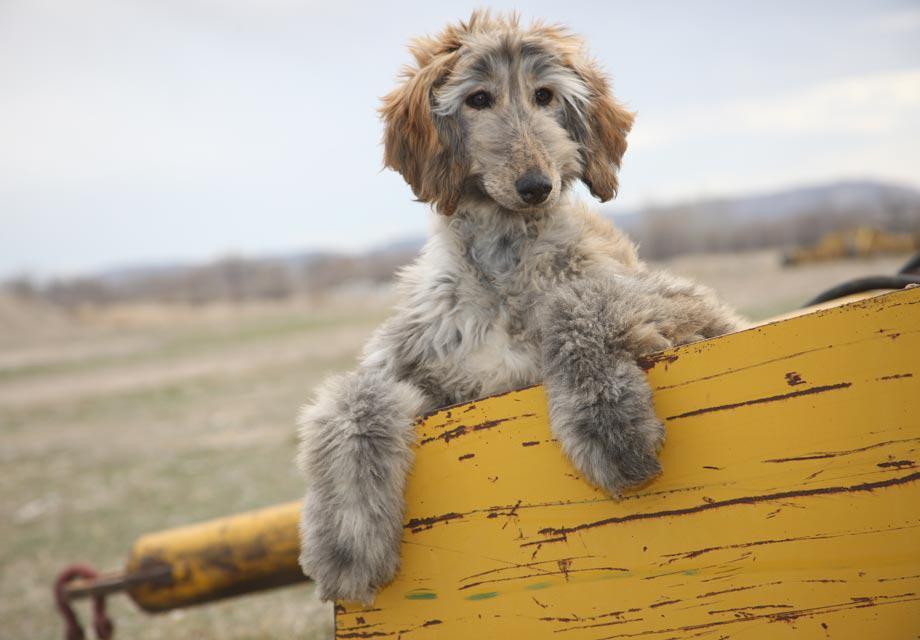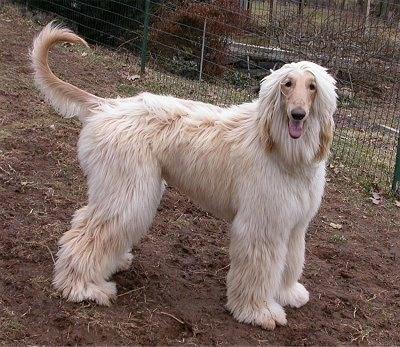The first image is the image on the left, the second image is the image on the right. Evaluate the accuracy of this statement regarding the images: "An image shows a creamy peach colored hound standing with tail curling upward.". Is it true? Answer yes or no. Yes. The first image is the image on the left, the second image is the image on the right. Analyze the images presented: Is the assertion "Both images show hounds standing with all four paws on the grass." valid? Answer yes or no. No. 